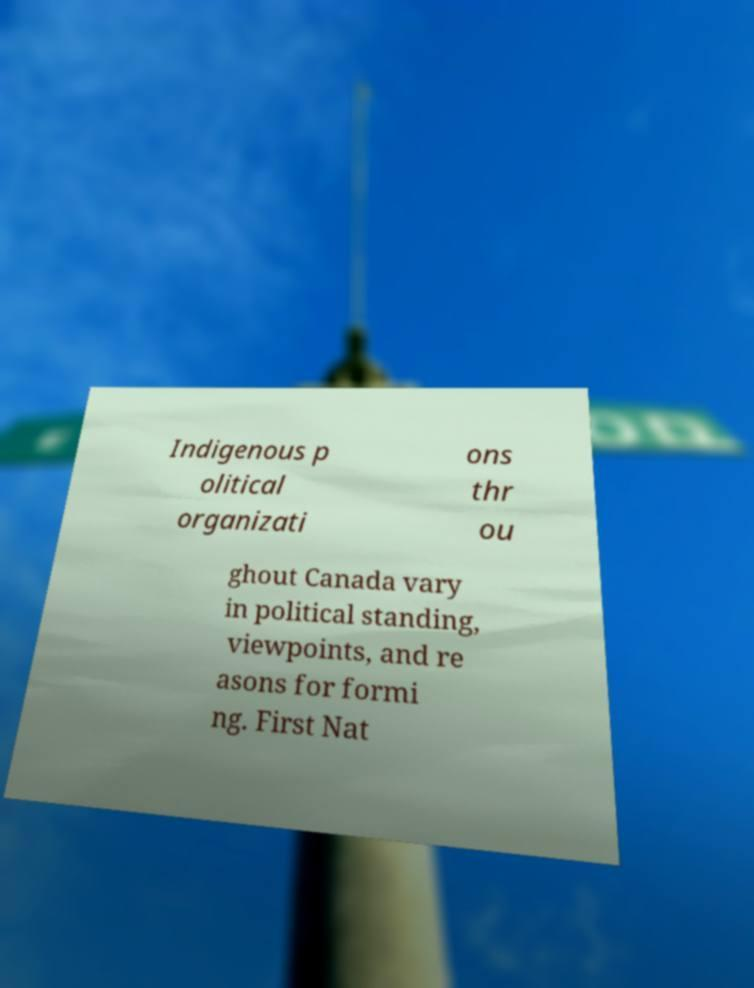Can you accurately transcribe the text from the provided image for me? Indigenous p olitical organizati ons thr ou ghout Canada vary in political standing, viewpoints, and re asons for formi ng. First Nat 